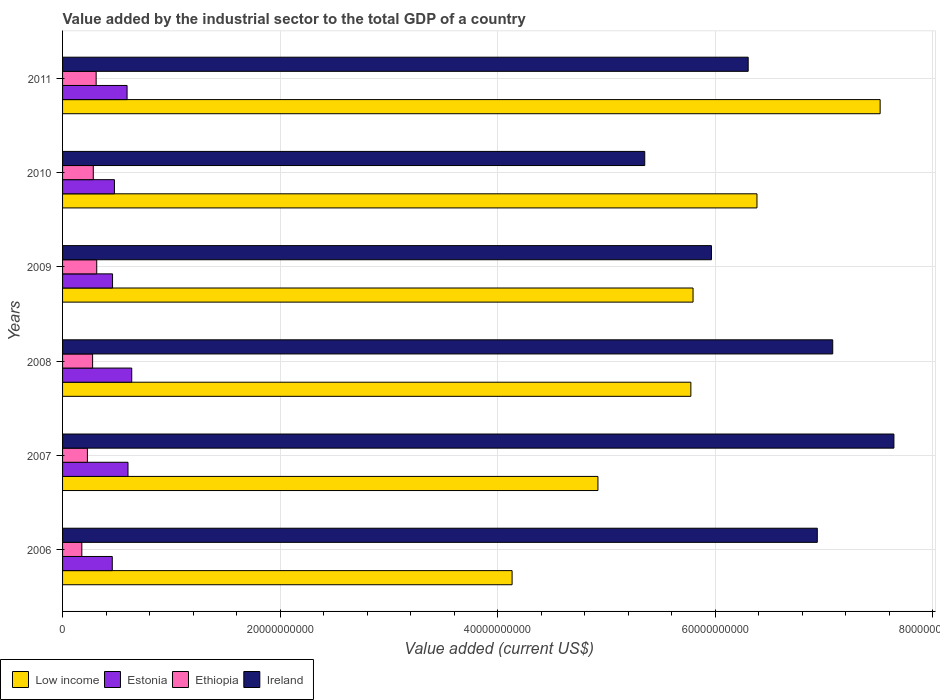How many groups of bars are there?
Keep it short and to the point. 6. Are the number of bars per tick equal to the number of legend labels?
Your response must be concise. Yes. Are the number of bars on each tick of the Y-axis equal?
Ensure brevity in your answer.  Yes. What is the value added by the industrial sector to the total GDP in Estonia in 2010?
Offer a terse response. 4.77e+09. Across all years, what is the maximum value added by the industrial sector to the total GDP in Ireland?
Your response must be concise. 7.64e+1. Across all years, what is the minimum value added by the industrial sector to the total GDP in Estonia?
Make the answer very short. 4.57e+09. What is the total value added by the industrial sector to the total GDP in Ireland in the graph?
Offer a terse response. 3.93e+11. What is the difference between the value added by the industrial sector to the total GDP in Low income in 2007 and that in 2011?
Offer a terse response. -2.59e+1. What is the difference between the value added by the industrial sector to the total GDP in Estonia in 2006 and the value added by the industrial sector to the total GDP in Ethiopia in 2011?
Provide a succinct answer. 1.48e+09. What is the average value added by the industrial sector to the total GDP in Ireland per year?
Provide a short and direct response. 6.55e+1. In the year 2006, what is the difference between the value added by the industrial sector to the total GDP in Low income and value added by the industrial sector to the total GDP in Ethiopia?
Provide a succinct answer. 3.96e+1. In how many years, is the value added by the industrial sector to the total GDP in Ethiopia greater than 52000000000 US$?
Keep it short and to the point. 0. What is the ratio of the value added by the industrial sector to the total GDP in Ireland in 2008 to that in 2010?
Make the answer very short. 1.32. Is the value added by the industrial sector to the total GDP in Estonia in 2007 less than that in 2008?
Provide a succinct answer. Yes. Is the difference between the value added by the industrial sector to the total GDP in Low income in 2007 and 2010 greater than the difference between the value added by the industrial sector to the total GDP in Ethiopia in 2007 and 2010?
Offer a very short reply. No. What is the difference between the highest and the second highest value added by the industrial sector to the total GDP in Ethiopia?
Offer a very short reply. 5.29e+07. What is the difference between the highest and the lowest value added by the industrial sector to the total GDP in Ireland?
Your response must be concise. 2.29e+1. In how many years, is the value added by the industrial sector to the total GDP in Ireland greater than the average value added by the industrial sector to the total GDP in Ireland taken over all years?
Provide a succinct answer. 3. What does the 1st bar from the top in 2008 represents?
Ensure brevity in your answer.  Ireland. Is it the case that in every year, the sum of the value added by the industrial sector to the total GDP in Ireland and value added by the industrial sector to the total GDP in Low income is greater than the value added by the industrial sector to the total GDP in Ethiopia?
Your answer should be very brief. Yes. Are all the bars in the graph horizontal?
Give a very brief answer. Yes. How many years are there in the graph?
Your response must be concise. 6. What is the difference between two consecutive major ticks on the X-axis?
Make the answer very short. 2.00e+1. Does the graph contain grids?
Your answer should be very brief. Yes. Where does the legend appear in the graph?
Your response must be concise. Bottom left. How many legend labels are there?
Offer a very short reply. 4. What is the title of the graph?
Keep it short and to the point. Value added by the industrial sector to the total GDP of a country. Does "Italy" appear as one of the legend labels in the graph?
Give a very brief answer. No. What is the label or title of the X-axis?
Your response must be concise. Value added (current US$). What is the Value added (current US$) in Low income in 2006?
Ensure brevity in your answer.  4.13e+1. What is the Value added (current US$) in Estonia in 2006?
Give a very brief answer. 4.57e+09. What is the Value added (current US$) of Ethiopia in 2006?
Offer a terse response. 1.77e+09. What is the Value added (current US$) in Ireland in 2006?
Provide a succinct answer. 6.94e+1. What is the Value added (current US$) of Low income in 2007?
Ensure brevity in your answer.  4.92e+1. What is the Value added (current US$) in Estonia in 2007?
Provide a short and direct response. 6.02e+09. What is the Value added (current US$) in Ethiopia in 2007?
Provide a short and direct response. 2.28e+09. What is the Value added (current US$) of Ireland in 2007?
Ensure brevity in your answer.  7.64e+1. What is the Value added (current US$) of Low income in 2008?
Your answer should be very brief. 5.78e+1. What is the Value added (current US$) of Estonia in 2008?
Give a very brief answer. 6.36e+09. What is the Value added (current US$) of Ethiopia in 2008?
Your answer should be very brief. 2.76e+09. What is the Value added (current US$) of Ireland in 2008?
Offer a terse response. 7.08e+1. What is the Value added (current US$) in Low income in 2009?
Make the answer very short. 5.80e+1. What is the Value added (current US$) of Estonia in 2009?
Keep it short and to the point. 4.60e+09. What is the Value added (current US$) in Ethiopia in 2009?
Ensure brevity in your answer.  3.14e+09. What is the Value added (current US$) of Ireland in 2009?
Your answer should be very brief. 5.97e+1. What is the Value added (current US$) of Low income in 2010?
Keep it short and to the point. 6.38e+1. What is the Value added (current US$) of Estonia in 2010?
Provide a succinct answer. 4.77e+09. What is the Value added (current US$) in Ethiopia in 2010?
Offer a terse response. 2.82e+09. What is the Value added (current US$) of Ireland in 2010?
Offer a very short reply. 5.35e+1. What is the Value added (current US$) in Low income in 2011?
Keep it short and to the point. 7.52e+1. What is the Value added (current US$) of Estonia in 2011?
Provide a succinct answer. 5.93e+09. What is the Value added (current US$) of Ethiopia in 2011?
Keep it short and to the point. 3.09e+09. What is the Value added (current US$) in Ireland in 2011?
Your answer should be very brief. 6.30e+1. Across all years, what is the maximum Value added (current US$) of Low income?
Provide a short and direct response. 7.52e+1. Across all years, what is the maximum Value added (current US$) of Estonia?
Offer a very short reply. 6.36e+09. Across all years, what is the maximum Value added (current US$) of Ethiopia?
Make the answer very short. 3.14e+09. Across all years, what is the maximum Value added (current US$) of Ireland?
Provide a succinct answer. 7.64e+1. Across all years, what is the minimum Value added (current US$) of Low income?
Provide a short and direct response. 4.13e+1. Across all years, what is the minimum Value added (current US$) in Estonia?
Keep it short and to the point. 4.57e+09. Across all years, what is the minimum Value added (current US$) in Ethiopia?
Offer a terse response. 1.77e+09. Across all years, what is the minimum Value added (current US$) in Ireland?
Offer a very short reply. 5.35e+1. What is the total Value added (current US$) of Low income in the graph?
Your answer should be compact. 3.45e+11. What is the total Value added (current US$) in Estonia in the graph?
Offer a very short reply. 3.22e+1. What is the total Value added (current US$) of Ethiopia in the graph?
Make the answer very short. 1.59e+1. What is the total Value added (current US$) in Ireland in the graph?
Keep it short and to the point. 3.93e+11. What is the difference between the Value added (current US$) in Low income in 2006 and that in 2007?
Give a very brief answer. -7.89e+09. What is the difference between the Value added (current US$) of Estonia in 2006 and that in 2007?
Offer a very short reply. -1.45e+09. What is the difference between the Value added (current US$) in Ethiopia in 2006 and that in 2007?
Offer a very short reply. -5.13e+08. What is the difference between the Value added (current US$) in Ireland in 2006 and that in 2007?
Offer a terse response. -7.04e+09. What is the difference between the Value added (current US$) of Low income in 2006 and that in 2008?
Provide a succinct answer. -1.64e+1. What is the difference between the Value added (current US$) in Estonia in 2006 and that in 2008?
Offer a terse response. -1.79e+09. What is the difference between the Value added (current US$) of Ethiopia in 2006 and that in 2008?
Your response must be concise. -9.91e+08. What is the difference between the Value added (current US$) in Ireland in 2006 and that in 2008?
Make the answer very short. -1.42e+09. What is the difference between the Value added (current US$) in Low income in 2006 and that in 2009?
Provide a short and direct response. -1.66e+1. What is the difference between the Value added (current US$) in Estonia in 2006 and that in 2009?
Your response must be concise. -2.50e+07. What is the difference between the Value added (current US$) of Ethiopia in 2006 and that in 2009?
Provide a short and direct response. -1.37e+09. What is the difference between the Value added (current US$) of Ireland in 2006 and that in 2009?
Provide a short and direct response. 9.73e+09. What is the difference between the Value added (current US$) of Low income in 2006 and that in 2010?
Offer a terse response. -2.25e+1. What is the difference between the Value added (current US$) in Estonia in 2006 and that in 2010?
Your answer should be very brief. -1.99e+08. What is the difference between the Value added (current US$) of Ethiopia in 2006 and that in 2010?
Your answer should be compact. -1.05e+09. What is the difference between the Value added (current US$) in Ireland in 2006 and that in 2010?
Provide a short and direct response. 1.59e+1. What is the difference between the Value added (current US$) in Low income in 2006 and that in 2011?
Your answer should be compact. -3.38e+1. What is the difference between the Value added (current US$) in Estonia in 2006 and that in 2011?
Make the answer very short. -1.36e+09. What is the difference between the Value added (current US$) of Ethiopia in 2006 and that in 2011?
Your response must be concise. -1.32e+09. What is the difference between the Value added (current US$) in Ireland in 2006 and that in 2011?
Give a very brief answer. 6.35e+09. What is the difference between the Value added (current US$) in Low income in 2007 and that in 2008?
Your response must be concise. -8.54e+09. What is the difference between the Value added (current US$) of Estonia in 2007 and that in 2008?
Offer a very short reply. -3.43e+08. What is the difference between the Value added (current US$) of Ethiopia in 2007 and that in 2008?
Your answer should be compact. -4.79e+08. What is the difference between the Value added (current US$) in Ireland in 2007 and that in 2008?
Provide a short and direct response. 5.63e+09. What is the difference between the Value added (current US$) in Low income in 2007 and that in 2009?
Offer a terse response. -8.74e+09. What is the difference between the Value added (current US$) in Estonia in 2007 and that in 2009?
Offer a terse response. 1.42e+09. What is the difference between the Value added (current US$) in Ethiopia in 2007 and that in 2009?
Make the answer very short. -8.57e+08. What is the difference between the Value added (current US$) of Ireland in 2007 and that in 2009?
Give a very brief answer. 1.68e+1. What is the difference between the Value added (current US$) of Low income in 2007 and that in 2010?
Offer a very short reply. -1.46e+1. What is the difference between the Value added (current US$) in Estonia in 2007 and that in 2010?
Your answer should be compact. 1.25e+09. What is the difference between the Value added (current US$) in Ethiopia in 2007 and that in 2010?
Make the answer very short. -5.40e+08. What is the difference between the Value added (current US$) in Ireland in 2007 and that in 2010?
Offer a terse response. 2.29e+1. What is the difference between the Value added (current US$) in Low income in 2007 and that in 2011?
Provide a short and direct response. -2.59e+1. What is the difference between the Value added (current US$) in Estonia in 2007 and that in 2011?
Offer a terse response. 8.51e+07. What is the difference between the Value added (current US$) in Ethiopia in 2007 and that in 2011?
Offer a terse response. -8.04e+08. What is the difference between the Value added (current US$) of Ireland in 2007 and that in 2011?
Make the answer very short. 1.34e+1. What is the difference between the Value added (current US$) of Low income in 2008 and that in 2009?
Your response must be concise. -2.02e+08. What is the difference between the Value added (current US$) of Estonia in 2008 and that in 2009?
Give a very brief answer. 1.76e+09. What is the difference between the Value added (current US$) in Ethiopia in 2008 and that in 2009?
Your answer should be compact. -3.78e+08. What is the difference between the Value added (current US$) in Ireland in 2008 and that in 2009?
Your answer should be compact. 1.12e+1. What is the difference between the Value added (current US$) in Low income in 2008 and that in 2010?
Your response must be concise. -6.08e+09. What is the difference between the Value added (current US$) of Estonia in 2008 and that in 2010?
Provide a succinct answer. 1.59e+09. What is the difference between the Value added (current US$) of Ethiopia in 2008 and that in 2010?
Offer a very short reply. -6.16e+07. What is the difference between the Value added (current US$) in Ireland in 2008 and that in 2010?
Your answer should be very brief. 1.73e+1. What is the difference between the Value added (current US$) in Low income in 2008 and that in 2011?
Make the answer very short. -1.74e+1. What is the difference between the Value added (current US$) in Estonia in 2008 and that in 2011?
Ensure brevity in your answer.  4.28e+08. What is the difference between the Value added (current US$) of Ethiopia in 2008 and that in 2011?
Your response must be concise. -3.25e+08. What is the difference between the Value added (current US$) in Ireland in 2008 and that in 2011?
Your answer should be compact. 7.77e+09. What is the difference between the Value added (current US$) of Low income in 2009 and that in 2010?
Provide a short and direct response. -5.88e+09. What is the difference between the Value added (current US$) in Estonia in 2009 and that in 2010?
Your response must be concise. -1.74e+08. What is the difference between the Value added (current US$) in Ethiopia in 2009 and that in 2010?
Give a very brief answer. 3.17e+08. What is the difference between the Value added (current US$) in Ireland in 2009 and that in 2010?
Provide a succinct answer. 6.13e+09. What is the difference between the Value added (current US$) of Low income in 2009 and that in 2011?
Your response must be concise. -1.72e+1. What is the difference between the Value added (current US$) of Estonia in 2009 and that in 2011?
Your answer should be very brief. -1.34e+09. What is the difference between the Value added (current US$) in Ethiopia in 2009 and that in 2011?
Offer a very short reply. 5.29e+07. What is the difference between the Value added (current US$) of Ireland in 2009 and that in 2011?
Keep it short and to the point. -3.38e+09. What is the difference between the Value added (current US$) in Low income in 2010 and that in 2011?
Ensure brevity in your answer.  -1.13e+1. What is the difference between the Value added (current US$) of Estonia in 2010 and that in 2011?
Keep it short and to the point. -1.16e+09. What is the difference between the Value added (current US$) in Ethiopia in 2010 and that in 2011?
Offer a very short reply. -2.64e+08. What is the difference between the Value added (current US$) in Ireland in 2010 and that in 2011?
Ensure brevity in your answer.  -9.51e+09. What is the difference between the Value added (current US$) of Low income in 2006 and the Value added (current US$) of Estonia in 2007?
Offer a terse response. 3.53e+1. What is the difference between the Value added (current US$) in Low income in 2006 and the Value added (current US$) in Ethiopia in 2007?
Ensure brevity in your answer.  3.90e+1. What is the difference between the Value added (current US$) of Low income in 2006 and the Value added (current US$) of Ireland in 2007?
Provide a short and direct response. -3.51e+1. What is the difference between the Value added (current US$) of Estonia in 2006 and the Value added (current US$) of Ethiopia in 2007?
Provide a succinct answer. 2.29e+09. What is the difference between the Value added (current US$) of Estonia in 2006 and the Value added (current US$) of Ireland in 2007?
Give a very brief answer. -7.19e+1. What is the difference between the Value added (current US$) in Ethiopia in 2006 and the Value added (current US$) in Ireland in 2007?
Your response must be concise. -7.47e+1. What is the difference between the Value added (current US$) in Low income in 2006 and the Value added (current US$) in Estonia in 2008?
Your answer should be compact. 3.50e+1. What is the difference between the Value added (current US$) of Low income in 2006 and the Value added (current US$) of Ethiopia in 2008?
Keep it short and to the point. 3.86e+1. What is the difference between the Value added (current US$) of Low income in 2006 and the Value added (current US$) of Ireland in 2008?
Provide a succinct answer. -2.95e+1. What is the difference between the Value added (current US$) in Estonia in 2006 and the Value added (current US$) in Ethiopia in 2008?
Make the answer very short. 1.81e+09. What is the difference between the Value added (current US$) of Estonia in 2006 and the Value added (current US$) of Ireland in 2008?
Your answer should be very brief. -6.62e+1. What is the difference between the Value added (current US$) of Ethiopia in 2006 and the Value added (current US$) of Ireland in 2008?
Make the answer very short. -6.90e+1. What is the difference between the Value added (current US$) of Low income in 2006 and the Value added (current US$) of Estonia in 2009?
Provide a succinct answer. 3.67e+1. What is the difference between the Value added (current US$) of Low income in 2006 and the Value added (current US$) of Ethiopia in 2009?
Give a very brief answer. 3.82e+1. What is the difference between the Value added (current US$) in Low income in 2006 and the Value added (current US$) in Ireland in 2009?
Provide a short and direct response. -1.83e+1. What is the difference between the Value added (current US$) in Estonia in 2006 and the Value added (current US$) in Ethiopia in 2009?
Provide a succinct answer. 1.43e+09. What is the difference between the Value added (current US$) in Estonia in 2006 and the Value added (current US$) in Ireland in 2009?
Provide a short and direct response. -5.51e+1. What is the difference between the Value added (current US$) of Ethiopia in 2006 and the Value added (current US$) of Ireland in 2009?
Your answer should be very brief. -5.79e+1. What is the difference between the Value added (current US$) of Low income in 2006 and the Value added (current US$) of Estonia in 2010?
Offer a very short reply. 3.66e+1. What is the difference between the Value added (current US$) in Low income in 2006 and the Value added (current US$) in Ethiopia in 2010?
Your response must be concise. 3.85e+1. What is the difference between the Value added (current US$) in Low income in 2006 and the Value added (current US$) in Ireland in 2010?
Ensure brevity in your answer.  -1.22e+1. What is the difference between the Value added (current US$) of Estonia in 2006 and the Value added (current US$) of Ethiopia in 2010?
Give a very brief answer. 1.75e+09. What is the difference between the Value added (current US$) in Estonia in 2006 and the Value added (current US$) in Ireland in 2010?
Your answer should be very brief. -4.90e+1. What is the difference between the Value added (current US$) in Ethiopia in 2006 and the Value added (current US$) in Ireland in 2010?
Offer a very short reply. -5.18e+1. What is the difference between the Value added (current US$) in Low income in 2006 and the Value added (current US$) in Estonia in 2011?
Provide a succinct answer. 3.54e+1. What is the difference between the Value added (current US$) in Low income in 2006 and the Value added (current US$) in Ethiopia in 2011?
Ensure brevity in your answer.  3.82e+1. What is the difference between the Value added (current US$) in Low income in 2006 and the Value added (current US$) in Ireland in 2011?
Ensure brevity in your answer.  -2.17e+1. What is the difference between the Value added (current US$) in Estonia in 2006 and the Value added (current US$) in Ethiopia in 2011?
Provide a short and direct response. 1.48e+09. What is the difference between the Value added (current US$) of Estonia in 2006 and the Value added (current US$) of Ireland in 2011?
Offer a terse response. -5.85e+1. What is the difference between the Value added (current US$) in Ethiopia in 2006 and the Value added (current US$) in Ireland in 2011?
Provide a short and direct response. -6.13e+1. What is the difference between the Value added (current US$) in Low income in 2007 and the Value added (current US$) in Estonia in 2008?
Make the answer very short. 4.29e+1. What is the difference between the Value added (current US$) in Low income in 2007 and the Value added (current US$) in Ethiopia in 2008?
Keep it short and to the point. 4.65e+1. What is the difference between the Value added (current US$) of Low income in 2007 and the Value added (current US$) of Ireland in 2008?
Your answer should be very brief. -2.16e+1. What is the difference between the Value added (current US$) in Estonia in 2007 and the Value added (current US$) in Ethiopia in 2008?
Offer a terse response. 3.25e+09. What is the difference between the Value added (current US$) of Estonia in 2007 and the Value added (current US$) of Ireland in 2008?
Make the answer very short. -6.48e+1. What is the difference between the Value added (current US$) of Ethiopia in 2007 and the Value added (current US$) of Ireland in 2008?
Offer a very short reply. -6.85e+1. What is the difference between the Value added (current US$) of Low income in 2007 and the Value added (current US$) of Estonia in 2009?
Provide a succinct answer. 4.46e+1. What is the difference between the Value added (current US$) in Low income in 2007 and the Value added (current US$) in Ethiopia in 2009?
Offer a very short reply. 4.61e+1. What is the difference between the Value added (current US$) in Low income in 2007 and the Value added (current US$) in Ireland in 2009?
Offer a very short reply. -1.04e+1. What is the difference between the Value added (current US$) in Estonia in 2007 and the Value added (current US$) in Ethiopia in 2009?
Give a very brief answer. 2.88e+09. What is the difference between the Value added (current US$) in Estonia in 2007 and the Value added (current US$) in Ireland in 2009?
Your answer should be compact. -5.36e+1. What is the difference between the Value added (current US$) of Ethiopia in 2007 and the Value added (current US$) of Ireland in 2009?
Offer a very short reply. -5.74e+1. What is the difference between the Value added (current US$) in Low income in 2007 and the Value added (current US$) in Estonia in 2010?
Your answer should be compact. 4.45e+1. What is the difference between the Value added (current US$) of Low income in 2007 and the Value added (current US$) of Ethiopia in 2010?
Offer a terse response. 4.64e+1. What is the difference between the Value added (current US$) of Low income in 2007 and the Value added (current US$) of Ireland in 2010?
Give a very brief answer. -4.30e+09. What is the difference between the Value added (current US$) of Estonia in 2007 and the Value added (current US$) of Ethiopia in 2010?
Your answer should be very brief. 3.19e+09. What is the difference between the Value added (current US$) in Estonia in 2007 and the Value added (current US$) in Ireland in 2010?
Provide a succinct answer. -4.75e+1. What is the difference between the Value added (current US$) of Ethiopia in 2007 and the Value added (current US$) of Ireland in 2010?
Ensure brevity in your answer.  -5.12e+1. What is the difference between the Value added (current US$) in Low income in 2007 and the Value added (current US$) in Estonia in 2011?
Offer a very short reply. 4.33e+1. What is the difference between the Value added (current US$) of Low income in 2007 and the Value added (current US$) of Ethiopia in 2011?
Offer a very short reply. 4.61e+1. What is the difference between the Value added (current US$) of Low income in 2007 and the Value added (current US$) of Ireland in 2011?
Ensure brevity in your answer.  -1.38e+1. What is the difference between the Value added (current US$) of Estonia in 2007 and the Value added (current US$) of Ethiopia in 2011?
Provide a short and direct response. 2.93e+09. What is the difference between the Value added (current US$) in Estonia in 2007 and the Value added (current US$) in Ireland in 2011?
Your answer should be very brief. -5.70e+1. What is the difference between the Value added (current US$) in Ethiopia in 2007 and the Value added (current US$) in Ireland in 2011?
Give a very brief answer. -6.08e+1. What is the difference between the Value added (current US$) in Low income in 2008 and the Value added (current US$) in Estonia in 2009?
Your answer should be compact. 5.32e+1. What is the difference between the Value added (current US$) of Low income in 2008 and the Value added (current US$) of Ethiopia in 2009?
Make the answer very short. 5.46e+1. What is the difference between the Value added (current US$) of Low income in 2008 and the Value added (current US$) of Ireland in 2009?
Your response must be concise. -1.89e+09. What is the difference between the Value added (current US$) of Estonia in 2008 and the Value added (current US$) of Ethiopia in 2009?
Ensure brevity in your answer.  3.22e+09. What is the difference between the Value added (current US$) of Estonia in 2008 and the Value added (current US$) of Ireland in 2009?
Keep it short and to the point. -5.33e+1. What is the difference between the Value added (current US$) of Ethiopia in 2008 and the Value added (current US$) of Ireland in 2009?
Your answer should be compact. -5.69e+1. What is the difference between the Value added (current US$) of Low income in 2008 and the Value added (current US$) of Estonia in 2010?
Your response must be concise. 5.30e+1. What is the difference between the Value added (current US$) of Low income in 2008 and the Value added (current US$) of Ethiopia in 2010?
Provide a succinct answer. 5.49e+1. What is the difference between the Value added (current US$) of Low income in 2008 and the Value added (current US$) of Ireland in 2010?
Your answer should be compact. 4.24e+09. What is the difference between the Value added (current US$) in Estonia in 2008 and the Value added (current US$) in Ethiopia in 2010?
Make the answer very short. 3.53e+09. What is the difference between the Value added (current US$) of Estonia in 2008 and the Value added (current US$) of Ireland in 2010?
Your answer should be very brief. -4.72e+1. What is the difference between the Value added (current US$) of Ethiopia in 2008 and the Value added (current US$) of Ireland in 2010?
Keep it short and to the point. -5.08e+1. What is the difference between the Value added (current US$) in Low income in 2008 and the Value added (current US$) in Estonia in 2011?
Your answer should be very brief. 5.18e+1. What is the difference between the Value added (current US$) of Low income in 2008 and the Value added (current US$) of Ethiopia in 2011?
Give a very brief answer. 5.47e+1. What is the difference between the Value added (current US$) in Low income in 2008 and the Value added (current US$) in Ireland in 2011?
Provide a succinct answer. -5.27e+09. What is the difference between the Value added (current US$) in Estonia in 2008 and the Value added (current US$) in Ethiopia in 2011?
Provide a succinct answer. 3.27e+09. What is the difference between the Value added (current US$) in Estonia in 2008 and the Value added (current US$) in Ireland in 2011?
Give a very brief answer. -5.67e+1. What is the difference between the Value added (current US$) of Ethiopia in 2008 and the Value added (current US$) of Ireland in 2011?
Your answer should be very brief. -6.03e+1. What is the difference between the Value added (current US$) in Low income in 2009 and the Value added (current US$) in Estonia in 2010?
Offer a very short reply. 5.32e+1. What is the difference between the Value added (current US$) of Low income in 2009 and the Value added (current US$) of Ethiopia in 2010?
Your answer should be very brief. 5.51e+1. What is the difference between the Value added (current US$) of Low income in 2009 and the Value added (current US$) of Ireland in 2010?
Offer a very short reply. 4.44e+09. What is the difference between the Value added (current US$) of Estonia in 2009 and the Value added (current US$) of Ethiopia in 2010?
Make the answer very short. 1.77e+09. What is the difference between the Value added (current US$) of Estonia in 2009 and the Value added (current US$) of Ireland in 2010?
Offer a terse response. -4.89e+1. What is the difference between the Value added (current US$) in Ethiopia in 2009 and the Value added (current US$) in Ireland in 2010?
Provide a short and direct response. -5.04e+1. What is the difference between the Value added (current US$) of Low income in 2009 and the Value added (current US$) of Estonia in 2011?
Provide a succinct answer. 5.20e+1. What is the difference between the Value added (current US$) of Low income in 2009 and the Value added (current US$) of Ethiopia in 2011?
Keep it short and to the point. 5.49e+1. What is the difference between the Value added (current US$) of Low income in 2009 and the Value added (current US$) of Ireland in 2011?
Make the answer very short. -5.07e+09. What is the difference between the Value added (current US$) of Estonia in 2009 and the Value added (current US$) of Ethiopia in 2011?
Make the answer very short. 1.51e+09. What is the difference between the Value added (current US$) in Estonia in 2009 and the Value added (current US$) in Ireland in 2011?
Offer a terse response. -5.84e+1. What is the difference between the Value added (current US$) in Ethiopia in 2009 and the Value added (current US$) in Ireland in 2011?
Your answer should be very brief. -5.99e+1. What is the difference between the Value added (current US$) in Low income in 2010 and the Value added (current US$) in Estonia in 2011?
Your response must be concise. 5.79e+1. What is the difference between the Value added (current US$) in Low income in 2010 and the Value added (current US$) in Ethiopia in 2011?
Your answer should be compact. 6.08e+1. What is the difference between the Value added (current US$) of Low income in 2010 and the Value added (current US$) of Ireland in 2011?
Your answer should be compact. 8.08e+08. What is the difference between the Value added (current US$) in Estonia in 2010 and the Value added (current US$) in Ethiopia in 2011?
Ensure brevity in your answer.  1.68e+09. What is the difference between the Value added (current US$) in Estonia in 2010 and the Value added (current US$) in Ireland in 2011?
Your answer should be very brief. -5.83e+1. What is the difference between the Value added (current US$) in Ethiopia in 2010 and the Value added (current US$) in Ireland in 2011?
Give a very brief answer. -6.02e+1. What is the average Value added (current US$) of Low income per year?
Ensure brevity in your answer.  5.75e+1. What is the average Value added (current US$) of Estonia per year?
Give a very brief answer. 5.37e+09. What is the average Value added (current US$) of Ethiopia per year?
Ensure brevity in your answer.  2.65e+09. What is the average Value added (current US$) in Ireland per year?
Make the answer very short. 6.55e+1. In the year 2006, what is the difference between the Value added (current US$) of Low income and Value added (current US$) of Estonia?
Keep it short and to the point. 3.68e+1. In the year 2006, what is the difference between the Value added (current US$) in Low income and Value added (current US$) in Ethiopia?
Offer a terse response. 3.96e+1. In the year 2006, what is the difference between the Value added (current US$) of Low income and Value added (current US$) of Ireland?
Your answer should be very brief. -2.81e+1. In the year 2006, what is the difference between the Value added (current US$) in Estonia and Value added (current US$) in Ethiopia?
Your answer should be very brief. 2.80e+09. In the year 2006, what is the difference between the Value added (current US$) of Estonia and Value added (current US$) of Ireland?
Provide a succinct answer. -6.48e+1. In the year 2006, what is the difference between the Value added (current US$) in Ethiopia and Value added (current US$) in Ireland?
Offer a terse response. -6.76e+1. In the year 2007, what is the difference between the Value added (current US$) of Low income and Value added (current US$) of Estonia?
Offer a very short reply. 4.32e+1. In the year 2007, what is the difference between the Value added (current US$) of Low income and Value added (current US$) of Ethiopia?
Give a very brief answer. 4.69e+1. In the year 2007, what is the difference between the Value added (current US$) of Low income and Value added (current US$) of Ireland?
Ensure brevity in your answer.  -2.72e+1. In the year 2007, what is the difference between the Value added (current US$) of Estonia and Value added (current US$) of Ethiopia?
Give a very brief answer. 3.73e+09. In the year 2007, what is the difference between the Value added (current US$) in Estonia and Value added (current US$) in Ireland?
Give a very brief answer. -7.04e+1. In the year 2007, what is the difference between the Value added (current US$) in Ethiopia and Value added (current US$) in Ireland?
Keep it short and to the point. -7.42e+1. In the year 2008, what is the difference between the Value added (current US$) of Low income and Value added (current US$) of Estonia?
Make the answer very short. 5.14e+1. In the year 2008, what is the difference between the Value added (current US$) of Low income and Value added (current US$) of Ethiopia?
Your answer should be very brief. 5.50e+1. In the year 2008, what is the difference between the Value added (current US$) of Low income and Value added (current US$) of Ireland?
Your response must be concise. -1.30e+1. In the year 2008, what is the difference between the Value added (current US$) in Estonia and Value added (current US$) in Ethiopia?
Offer a terse response. 3.60e+09. In the year 2008, what is the difference between the Value added (current US$) in Estonia and Value added (current US$) in Ireland?
Offer a very short reply. -6.45e+1. In the year 2008, what is the difference between the Value added (current US$) in Ethiopia and Value added (current US$) in Ireland?
Offer a terse response. -6.80e+1. In the year 2009, what is the difference between the Value added (current US$) in Low income and Value added (current US$) in Estonia?
Offer a very short reply. 5.34e+1. In the year 2009, what is the difference between the Value added (current US$) of Low income and Value added (current US$) of Ethiopia?
Ensure brevity in your answer.  5.48e+1. In the year 2009, what is the difference between the Value added (current US$) in Low income and Value added (current US$) in Ireland?
Keep it short and to the point. -1.69e+09. In the year 2009, what is the difference between the Value added (current US$) of Estonia and Value added (current US$) of Ethiopia?
Your answer should be very brief. 1.45e+09. In the year 2009, what is the difference between the Value added (current US$) in Estonia and Value added (current US$) in Ireland?
Provide a short and direct response. -5.51e+1. In the year 2009, what is the difference between the Value added (current US$) in Ethiopia and Value added (current US$) in Ireland?
Provide a succinct answer. -5.65e+1. In the year 2010, what is the difference between the Value added (current US$) of Low income and Value added (current US$) of Estonia?
Provide a short and direct response. 5.91e+1. In the year 2010, what is the difference between the Value added (current US$) of Low income and Value added (current US$) of Ethiopia?
Provide a short and direct response. 6.10e+1. In the year 2010, what is the difference between the Value added (current US$) in Low income and Value added (current US$) in Ireland?
Ensure brevity in your answer.  1.03e+1. In the year 2010, what is the difference between the Value added (current US$) in Estonia and Value added (current US$) in Ethiopia?
Offer a very short reply. 1.95e+09. In the year 2010, what is the difference between the Value added (current US$) of Estonia and Value added (current US$) of Ireland?
Offer a terse response. -4.88e+1. In the year 2010, what is the difference between the Value added (current US$) of Ethiopia and Value added (current US$) of Ireland?
Keep it short and to the point. -5.07e+1. In the year 2011, what is the difference between the Value added (current US$) in Low income and Value added (current US$) in Estonia?
Offer a very short reply. 6.92e+1. In the year 2011, what is the difference between the Value added (current US$) in Low income and Value added (current US$) in Ethiopia?
Keep it short and to the point. 7.21e+1. In the year 2011, what is the difference between the Value added (current US$) in Low income and Value added (current US$) in Ireland?
Give a very brief answer. 1.21e+1. In the year 2011, what is the difference between the Value added (current US$) in Estonia and Value added (current US$) in Ethiopia?
Provide a succinct answer. 2.84e+09. In the year 2011, what is the difference between the Value added (current US$) in Estonia and Value added (current US$) in Ireland?
Provide a succinct answer. -5.71e+1. In the year 2011, what is the difference between the Value added (current US$) in Ethiopia and Value added (current US$) in Ireland?
Ensure brevity in your answer.  -5.99e+1. What is the ratio of the Value added (current US$) in Low income in 2006 to that in 2007?
Your answer should be very brief. 0.84. What is the ratio of the Value added (current US$) of Estonia in 2006 to that in 2007?
Provide a succinct answer. 0.76. What is the ratio of the Value added (current US$) of Ethiopia in 2006 to that in 2007?
Provide a succinct answer. 0.78. What is the ratio of the Value added (current US$) in Ireland in 2006 to that in 2007?
Offer a terse response. 0.91. What is the ratio of the Value added (current US$) of Low income in 2006 to that in 2008?
Ensure brevity in your answer.  0.72. What is the ratio of the Value added (current US$) of Estonia in 2006 to that in 2008?
Make the answer very short. 0.72. What is the ratio of the Value added (current US$) in Ethiopia in 2006 to that in 2008?
Provide a short and direct response. 0.64. What is the ratio of the Value added (current US$) of Ireland in 2006 to that in 2008?
Ensure brevity in your answer.  0.98. What is the ratio of the Value added (current US$) of Low income in 2006 to that in 2009?
Ensure brevity in your answer.  0.71. What is the ratio of the Value added (current US$) in Ethiopia in 2006 to that in 2009?
Provide a succinct answer. 0.56. What is the ratio of the Value added (current US$) of Ireland in 2006 to that in 2009?
Your answer should be compact. 1.16. What is the ratio of the Value added (current US$) in Low income in 2006 to that in 2010?
Your answer should be compact. 0.65. What is the ratio of the Value added (current US$) in Estonia in 2006 to that in 2010?
Offer a terse response. 0.96. What is the ratio of the Value added (current US$) in Ethiopia in 2006 to that in 2010?
Offer a very short reply. 0.63. What is the ratio of the Value added (current US$) of Ireland in 2006 to that in 2010?
Offer a very short reply. 1.3. What is the ratio of the Value added (current US$) in Low income in 2006 to that in 2011?
Offer a terse response. 0.55. What is the ratio of the Value added (current US$) in Estonia in 2006 to that in 2011?
Make the answer very short. 0.77. What is the ratio of the Value added (current US$) in Ethiopia in 2006 to that in 2011?
Your response must be concise. 0.57. What is the ratio of the Value added (current US$) of Ireland in 2006 to that in 2011?
Make the answer very short. 1.1. What is the ratio of the Value added (current US$) of Low income in 2007 to that in 2008?
Provide a short and direct response. 0.85. What is the ratio of the Value added (current US$) of Estonia in 2007 to that in 2008?
Give a very brief answer. 0.95. What is the ratio of the Value added (current US$) in Ethiopia in 2007 to that in 2008?
Offer a very short reply. 0.83. What is the ratio of the Value added (current US$) in Ireland in 2007 to that in 2008?
Offer a very short reply. 1.08. What is the ratio of the Value added (current US$) in Low income in 2007 to that in 2009?
Your answer should be compact. 0.85. What is the ratio of the Value added (current US$) of Estonia in 2007 to that in 2009?
Provide a succinct answer. 1.31. What is the ratio of the Value added (current US$) in Ethiopia in 2007 to that in 2009?
Keep it short and to the point. 0.73. What is the ratio of the Value added (current US$) of Ireland in 2007 to that in 2009?
Your answer should be very brief. 1.28. What is the ratio of the Value added (current US$) in Low income in 2007 to that in 2010?
Give a very brief answer. 0.77. What is the ratio of the Value added (current US$) in Estonia in 2007 to that in 2010?
Provide a short and direct response. 1.26. What is the ratio of the Value added (current US$) in Ethiopia in 2007 to that in 2010?
Offer a terse response. 0.81. What is the ratio of the Value added (current US$) of Ireland in 2007 to that in 2010?
Your answer should be compact. 1.43. What is the ratio of the Value added (current US$) of Low income in 2007 to that in 2011?
Your answer should be compact. 0.65. What is the ratio of the Value added (current US$) in Estonia in 2007 to that in 2011?
Make the answer very short. 1.01. What is the ratio of the Value added (current US$) in Ethiopia in 2007 to that in 2011?
Keep it short and to the point. 0.74. What is the ratio of the Value added (current US$) of Ireland in 2007 to that in 2011?
Provide a short and direct response. 1.21. What is the ratio of the Value added (current US$) in Low income in 2008 to that in 2009?
Your answer should be very brief. 1. What is the ratio of the Value added (current US$) in Estonia in 2008 to that in 2009?
Offer a terse response. 1.38. What is the ratio of the Value added (current US$) of Ethiopia in 2008 to that in 2009?
Ensure brevity in your answer.  0.88. What is the ratio of the Value added (current US$) in Ireland in 2008 to that in 2009?
Provide a short and direct response. 1.19. What is the ratio of the Value added (current US$) of Low income in 2008 to that in 2010?
Keep it short and to the point. 0.9. What is the ratio of the Value added (current US$) of Estonia in 2008 to that in 2010?
Offer a very short reply. 1.33. What is the ratio of the Value added (current US$) of Ethiopia in 2008 to that in 2010?
Your response must be concise. 0.98. What is the ratio of the Value added (current US$) in Ireland in 2008 to that in 2010?
Provide a succinct answer. 1.32. What is the ratio of the Value added (current US$) of Low income in 2008 to that in 2011?
Keep it short and to the point. 0.77. What is the ratio of the Value added (current US$) in Estonia in 2008 to that in 2011?
Offer a very short reply. 1.07. What is the ratio of the Value added (current US$) in Ethiopia in 2008 to that in 2011?
Make the answer very short. 0.89. What is the ratio of the Value added (current US$) of Ireland in 2008 to that in 2011?
Your answer should be very brief. 1.12. What is the ratio of the Value added (current US$) in Low income in 2009 to that in 2010?
Your response must be concise. 0.91. What is the ratio of the Value added (current US$) of Estonia in 2009 to that in 2010?
Your answer should be very brief. 0.96. What is the ratio of the Value added (current US$) of Ethiopia in 2009 to that in 2010?
Your response must be concise. 1.11. What is the ratio of the Value added (current US$) in Ireland in 2009 to that in 2010?
Provide a short and direct response. 1.11. What is the ratio of the Value added (current US$) of Low income in 2009 to that in 2011?
Your answer should be compact. 0.77. What is the ratio of the Value added (current US$) of Estonia in 2009 to that in 2011?
Provide a succinct answer. 0.77. What is the ratio of the Value added (current US$) of Ethiopia in 2009 to that in 2011?
Make the answer very short. 1.02. What is the ratio of the Value added (current US$) of Ireland in 2009 to that in 2011?
Your answer should be compact. 0.95. What is the ratio of the Value added (current US$) in Low income in 2010 to that in 2011?
Your answer should be very brief. 0.85. What is the ratio of the Value added (current US$) in Estonia in 2010 to that in 2011?
Provide a short and direct response. 0.8. What is the ratio of the Value added (current US$) in Ethiopia in 2010 to that in 2011?
Your answer should be compact. 0.91. What is the ratio of the Value added (current US$) of Ireland in 2010 to that in 2011?
Provide a short and direct response. 0.85. What is the difference between the highest and the second highest Value added (current US$) of Low income?
Your answer should be compact. 1.13e+1. What is the difference between the highest and the second highest Value added (current US$) of Estonia?
Provide a short and direct response. 3.43e+08. What is the difference between the highest and the second highest Value added (current US$) in Ethiopia?
Make the answer very short. 5.29e+07. What is the difference between the highest and the second highest Value added (current US$) in Ireland?
Offer a very short reply. 5.63e+09. What is the difference between the highest and the lowest Value added (current US$) in Low income?
Your answer should be very brief. 3.38e+1. What is the difference between the highest and the lowest Value added (current US$) in Estonia?
Your answer should be very brief. 1.79e+09. What is the difference between the highest and the lowest Value added (current US$) in Ethiopia?
Offer a very short reply. 1.37e+09. What is the difference between the highest and the lowest Value added (current US$) in Ireland?
Ensure brevity in your answer.  2.29e+1. 